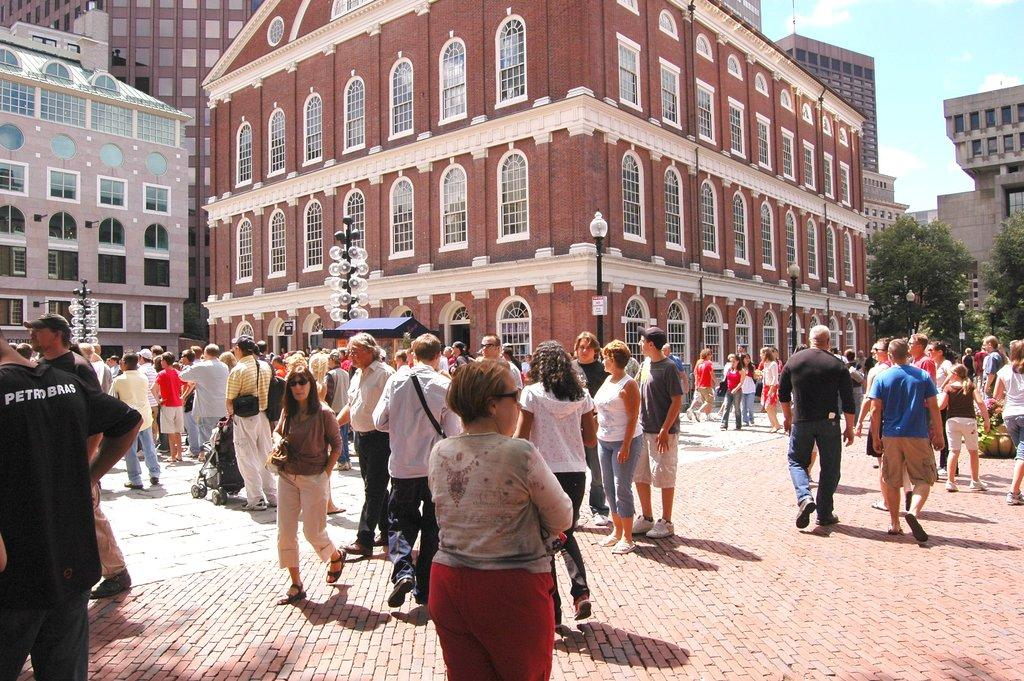<image>
Present a compact description of the photo's key features. a courtyard in Europe with people including someone wearing a black PetroBras shirt 